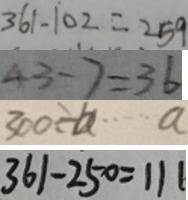Convert formula to latex. <formula><loc_0><loc_0><loc_500><loc_500>3 6 1 - 1 0 2 = 2 5 9 
 4 3 - 7 = 3 6 
 3 0 0 \div b \cdots a 
 3 6 1 - 2 5 0 = 1 1 1</formula> 